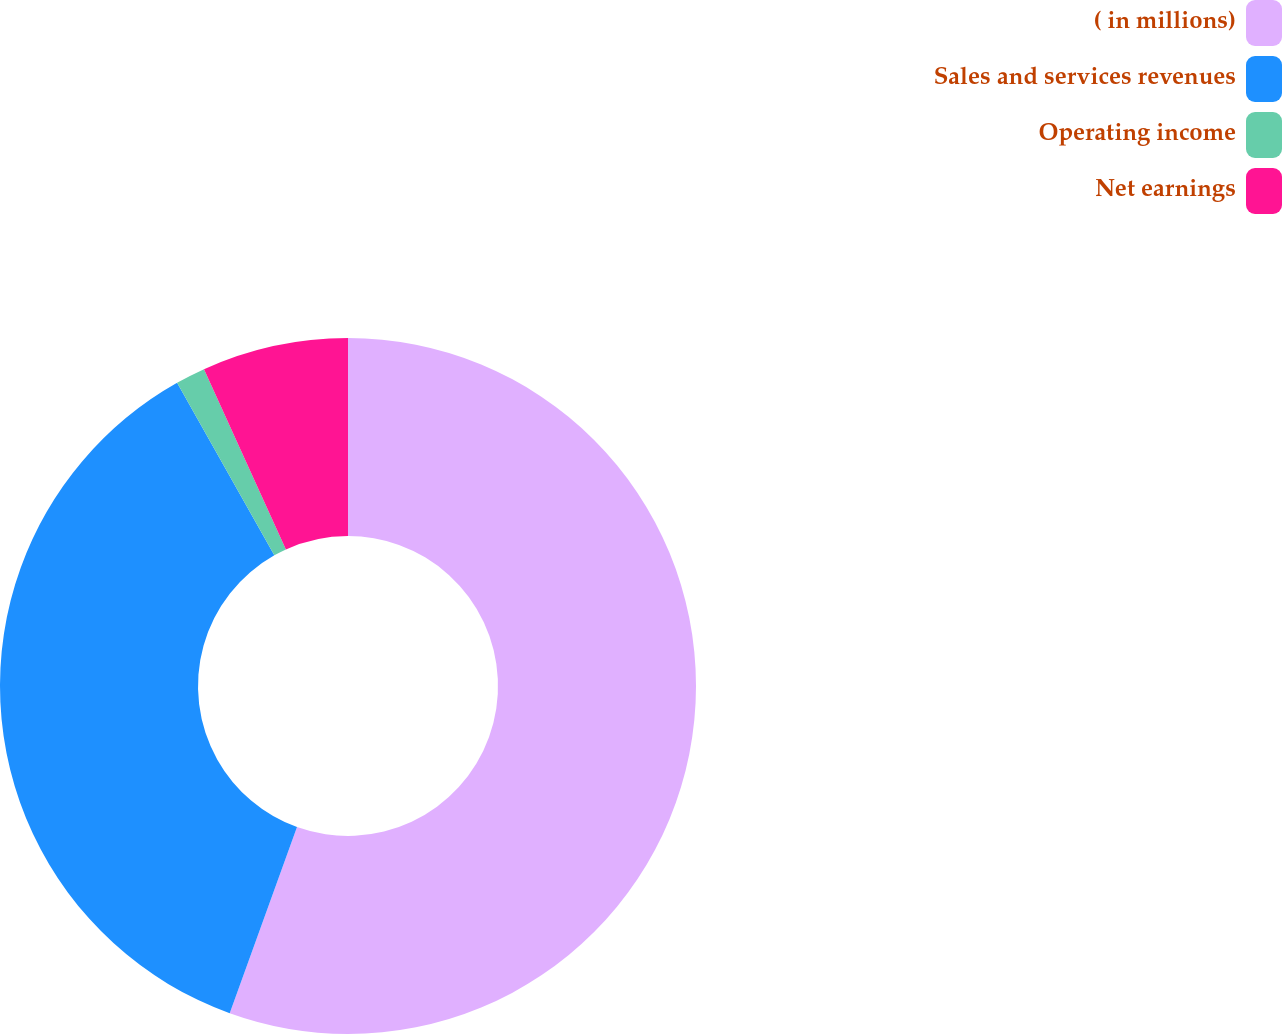Convert chart. <chart><loc_0><loc_0><loc_500><loc_500><pie_chart><fcel>( in millions)<fcel>Sales and services revenues<fcel>Operating income<fcel>Net earnings<nl><fcel>55.52%<fcel>36.31%<fcel>1.38%<fcel>6.79%<nl></chart> 